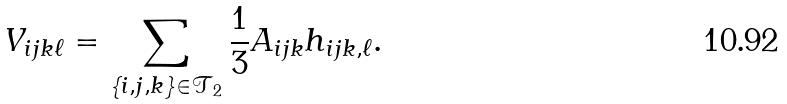Convert formula to latex. <formula><loc_0><loc_0><loc_500><loc_500>V _ { i j k \ell } = \sum _ { \left \{ i , j , k \right \} \in \mathcal { T } _ { 2 } } \frac { 1 } { 3 } A _ { i j k } h _ { i j k , \ell } .</formula> 